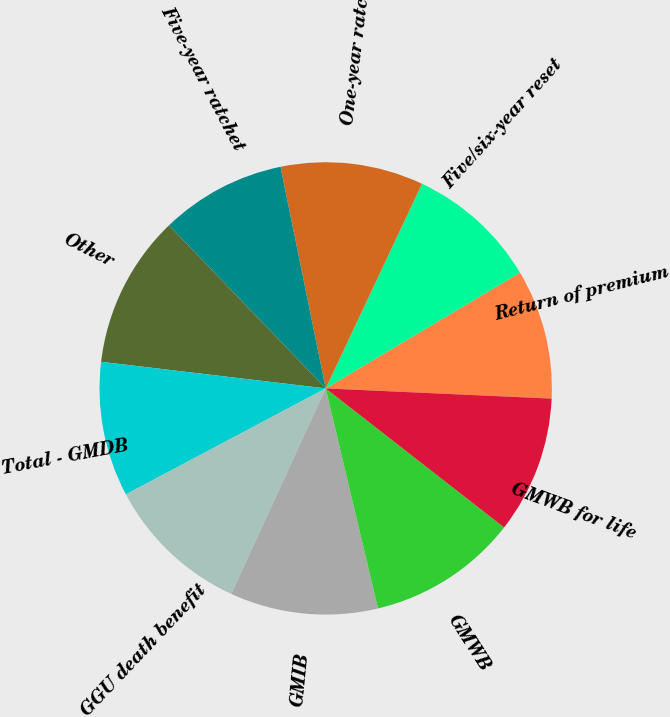<chart> <loc_0><loc_0><loc_500><loc_500><pie_chart><fcel>Return of premium<fcel>Five/six-year reset<fcel>One-year ratchet<fcel>Five-year ratchet<fcel>Other<fcel>Total - GMDB<fcel>GGU death benefit<fcel>GMIB<fcel>GMWB<fcel>GMWB for life<nl><fcel>9.27%<fcel>9.45%<fcel>10.2%<fcel>8.98%<fcel>10.94%<fcel>9.64%<fcel>10.38%<fcel>10.57%<fcel>10.75%<fcel>9.82%<nl></chart> 